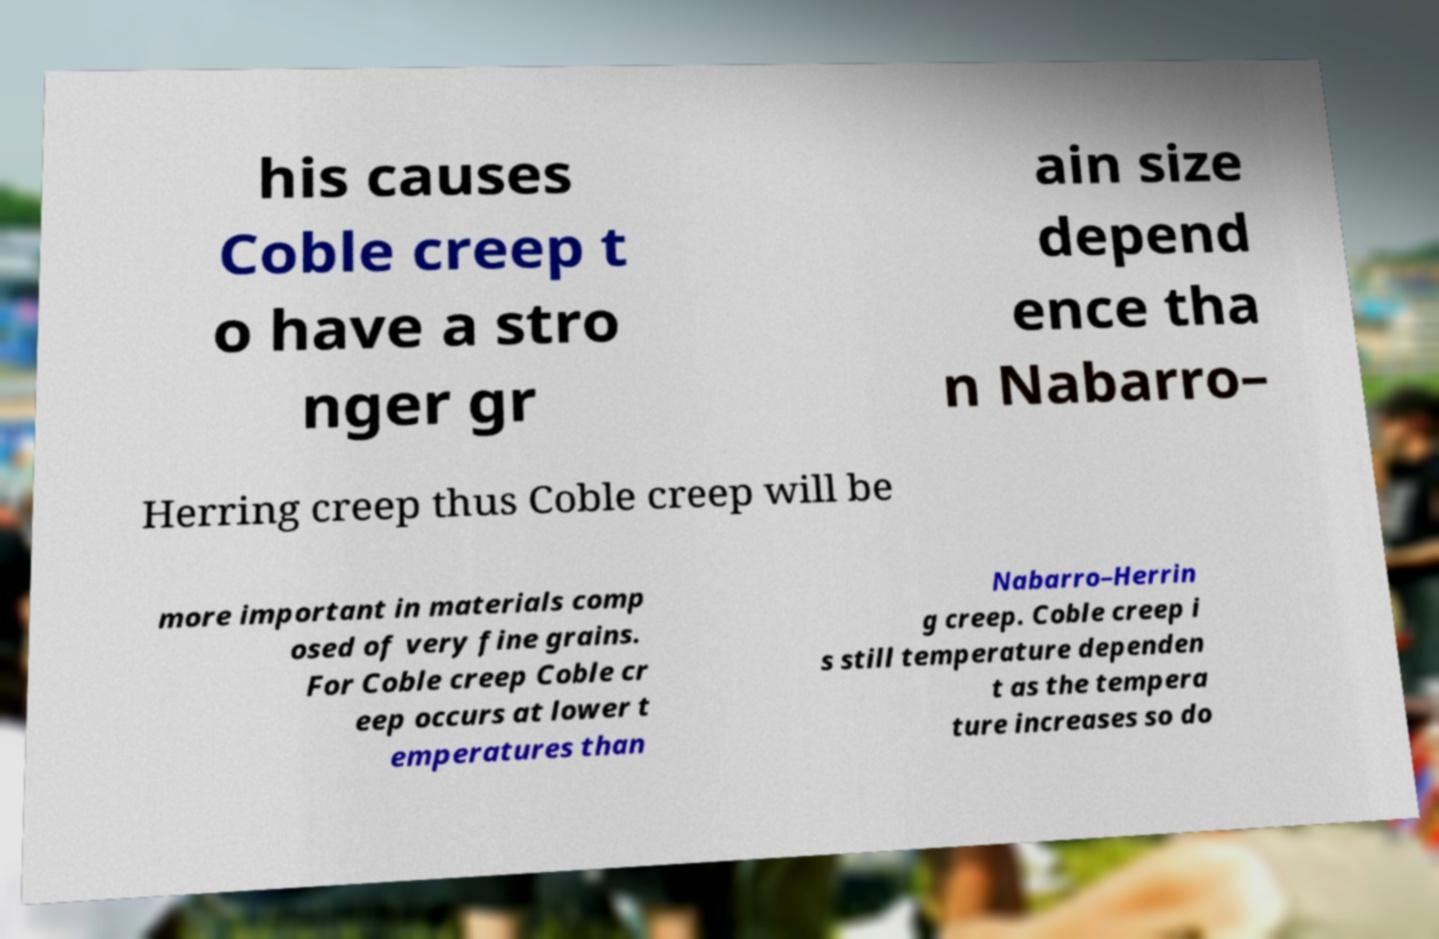Can you accurately transcribe the text from the provided image for me? his causes Coble creep t o have a stro nger gr ain size depend ence tha n Nabarro– Herring creep thus Coble creep will be more important in materials comp osed of very fine grains. For Coble creep Coble cr eep occurs at lower t emperatures than Nabarro–Herrin g creep. Coble creep i s still temperature dependen t as the tempera ture increases so do 